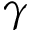<formula> <loc_0><loc_0><loc_500><loc_500>\gamma</formula> 